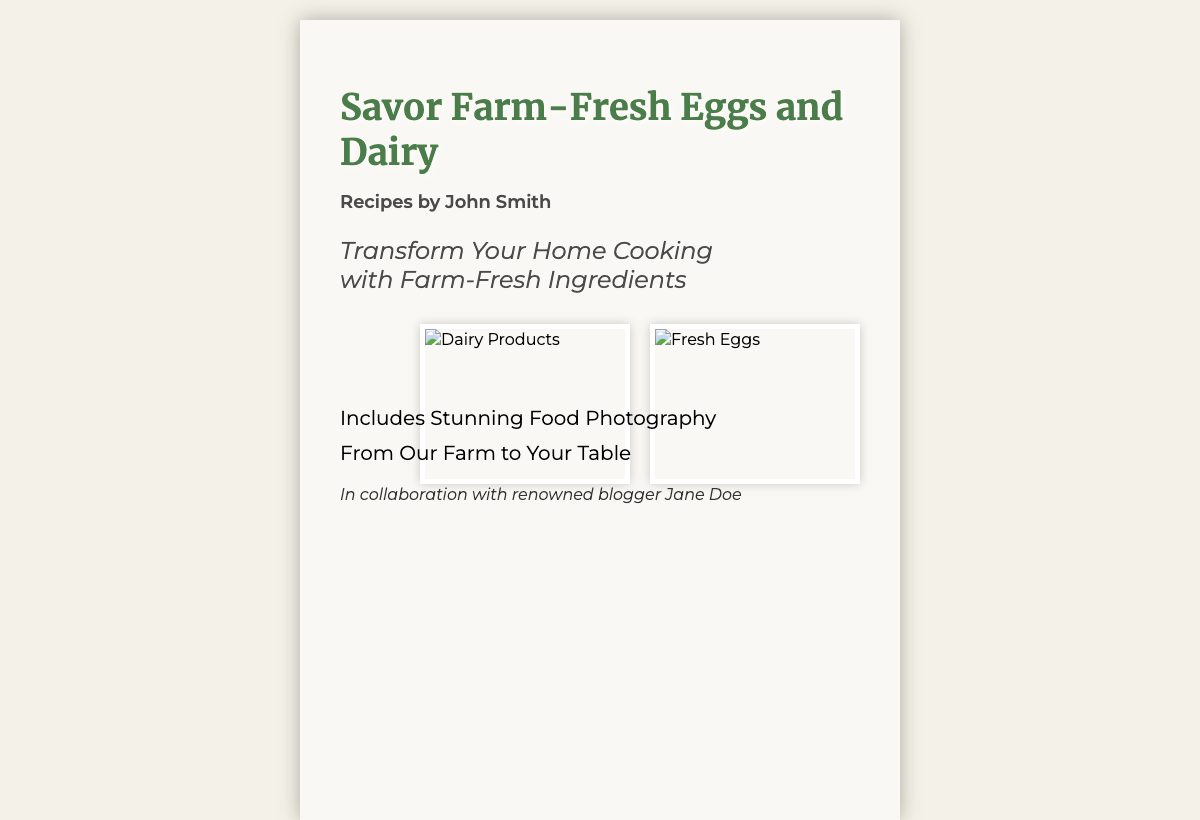What is the title of the book? The title is prominently displayed at the top of the cover, indicating the focus of the recipes.
Answer: Savor Farm-Fresh Eggs and Dairy Who is the author of the recipes? The author's name is found below the title, indicating who created the recipes.
Answer: John Smith What is the subtitle of the book? The subtitle provides additional context on the content and approach of the book.
Answer: Transform Your Home Cooking with Farm-Fresh Ingredients What types of products are highlighted in the images? The images displayed on the cover represent the main ingredients featured in the recipes.
Answer: Dairy Products and Fresh Eggs What is included in addition to the recipes? This statement provides insight into supplementary material within the book.
Answer: Stunning Food Photography Who collaborated on this book? The collaboration mentioned adds credibility and context about the recipe source.
Answer: Jane Doe 